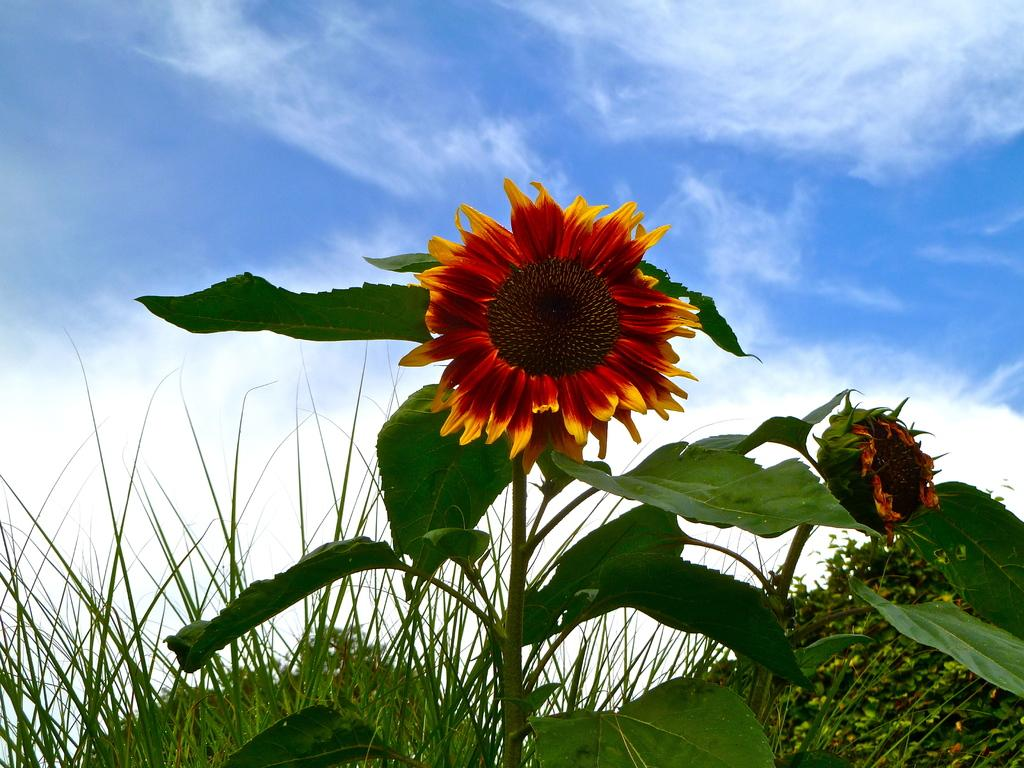What is the main subject in the center of the image? There is a sunflower in the center of the image. What can be seen in the background of the image? There is sky visible in the background of the image, along with clouds and plants. What type of judgment is the judge making in the image? There is no judge present in the image, as it features a sunflower and background elements. 